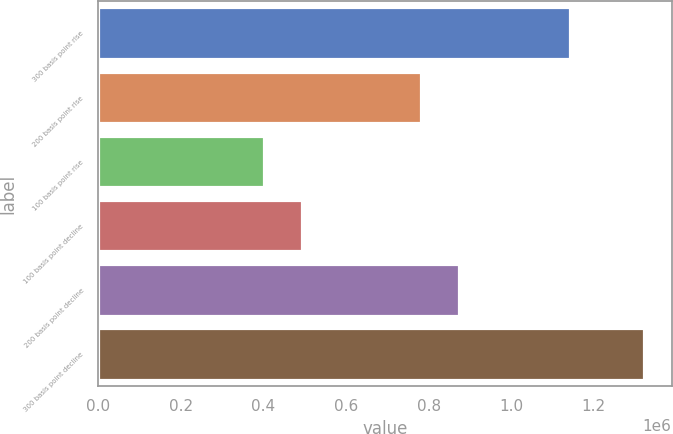Convert chart to OTSL. <chart><loc_0><loc_0><loc_500><loc_500><bar_chart><fcel>300 basis point rise<fcel>200 basis point rise<fcel>100 basis point rise<fcel>100 basis point decline<fcel>200 basis point decline<fcel>300 basis point decline<nl><fcel>1.14172e+06<fcel>782367<fcel>401988<fcel>494021<fcel>874400<fcel>1.32232e+06<nl></chart> 